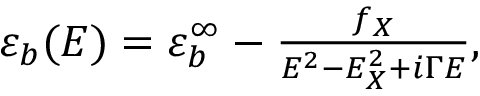Convert formula to latex. <formula><loc_0><loc_0><loc_500><loc_500>\begin{array} { r } { \varepsilon _ { b } ( E ) = \varepsilon _ { b } ^ { \infty } - \frac { f _ { X } } { E ^ { 2 } - E _ { X } ^ { 2 } + i \Gamma E } , } \end{array}</formula> 